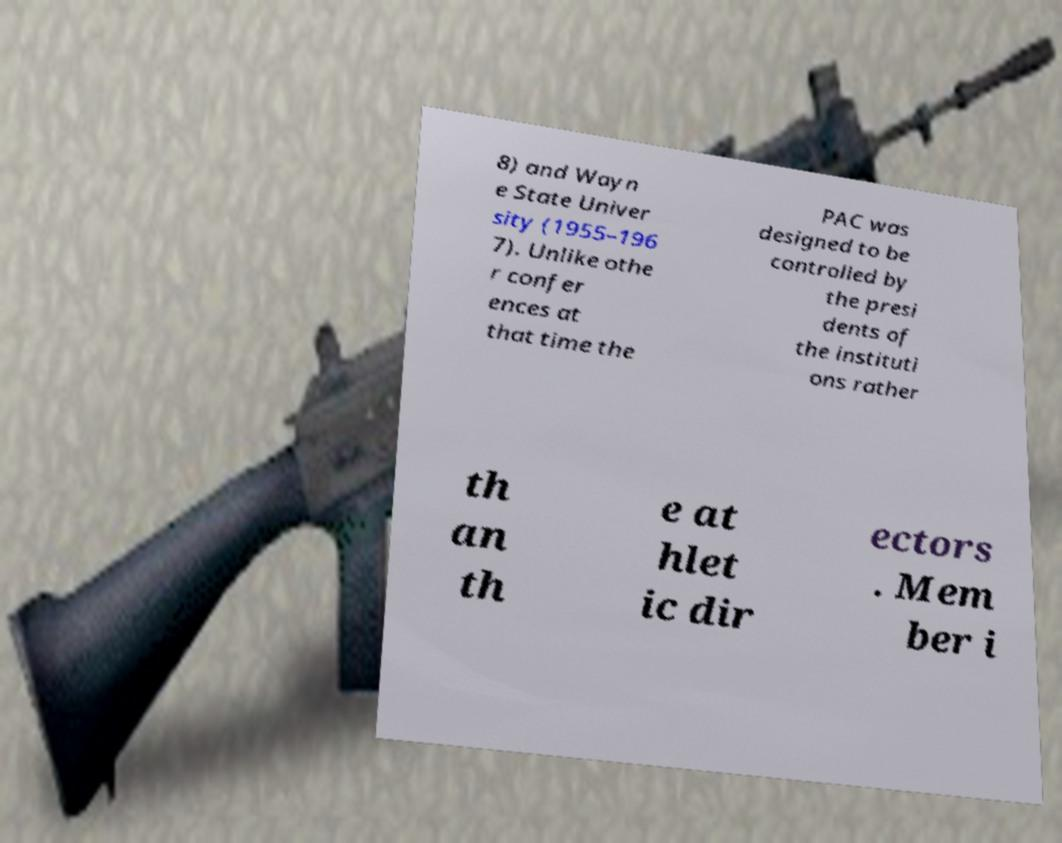Please identify and transcribe the text found in this image. 8) and Wayn e State Univer sity (1955–196 7). Unlike othe r confer ences at that time the PAC was designed to be controlled by the presi dents of the instituti ons rather th an th e at hlet ic dir ectors . Mem ber i 